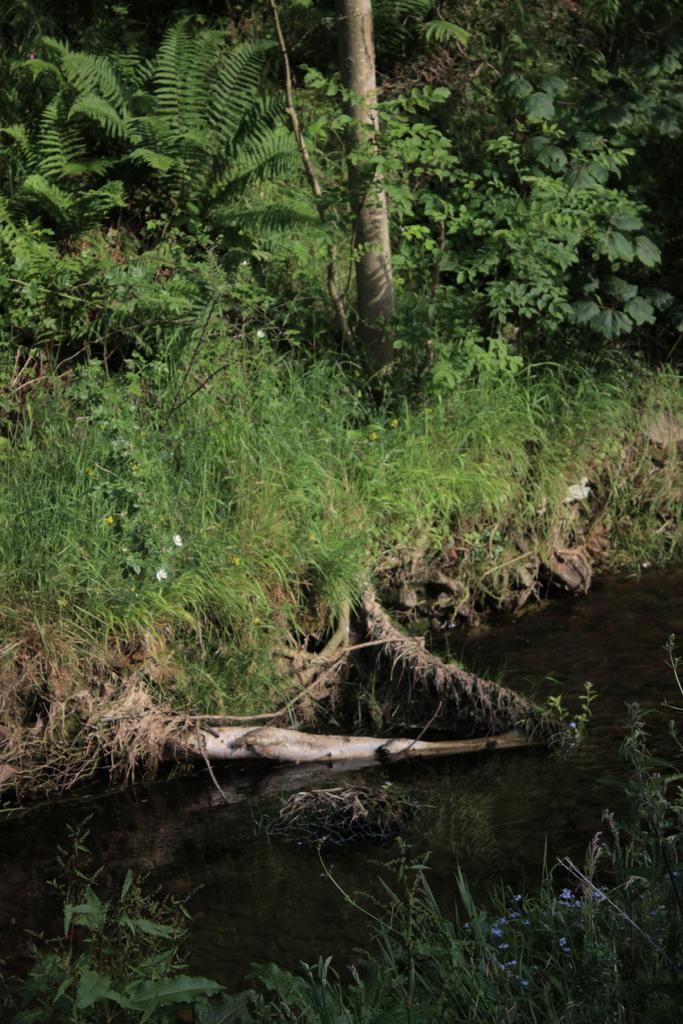What is the primary element visible in the image? There is water in the image. What types of vegetation can be seen at the bottom of the image? There are plants at the bottom of the image. What type of vegetation can be seen at the top of the image? There is grass at the top of the image. What types of vegetation and land features can be seen on the land at the top of the image? There are plants and trees on the land at the top of the image. What type of voice can be heard coming from the representative in the image? There is no representative or voice present in the image; it features water, plants, and trees. 